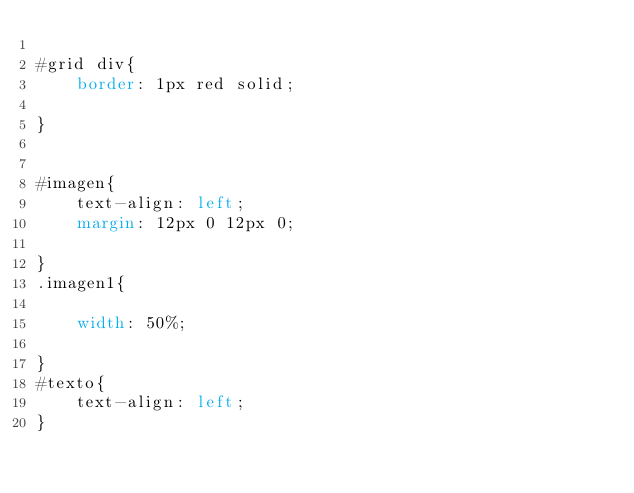Convert code to text. <code><loc_0><loc_0><loc_500><loc_500><_CSS_>
#grid div{
    border: 1px red solid;
    
}


#imagen{
    text-align: left;
    margin: 12px 0 12px 0;
    
}
.imagen1{

    width: 50%;
    
}
#texto{
    text-align: left; 
}</code> 